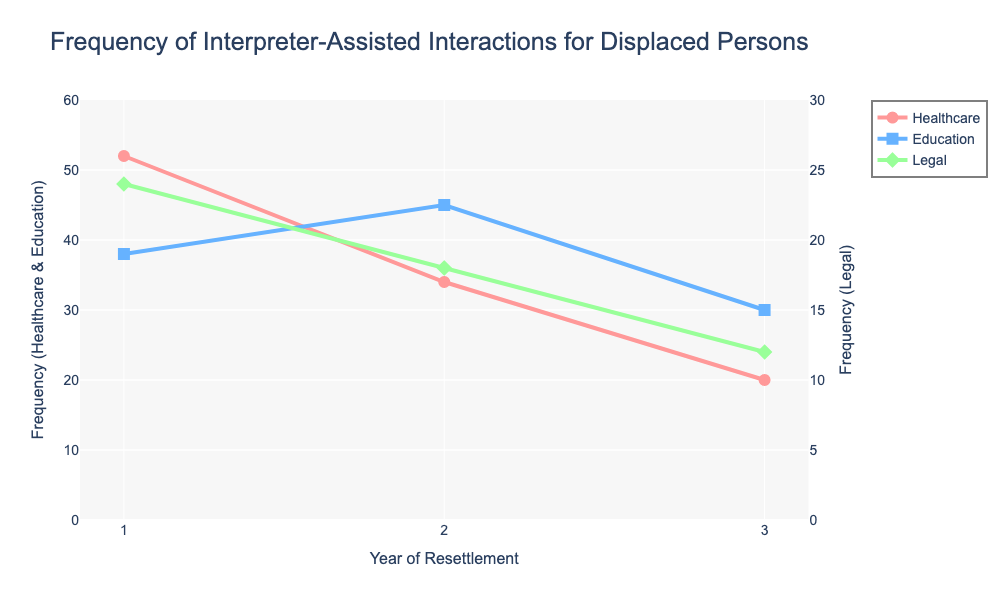What is the frequency of interpreter-assisted interactions in healthcare in the first year? The frequency of interpreter-assisted interactions in healthcare in the first year can be directly read from the figure where the year is marked as 1 and the healthcare data is depicted by the red line.
Answer: 52 Which public service area had the highest frequency of interpreter-assisted interactions in the second year? By comparing the frequency values for healthcare (34), education (45), and legal (18) in the second year, education has the highest frequency.
Answer: Education How did the frequency of interpreter-assisted interactions in the legal service area change from the first to the third year? To find the change in frequency for legal services, subtract the value in the third year (12) from the value in the first year (24).
Answer: Decreased by 12 What's the average frequency of interpreter-assisted interactions in all three public service areas in the first year? Add the frequency values for healthcare (52), education (38), and legal (24) in the first year and divide by 3. (52 + 38 + 24) / 3 = 114 / 3
Answer: 38 Between which years did education see the highest increase in interpreter-assisted interactions? Subtract the frequency of year 1 from year 2 (45 - 38 = 7) and of year 2 from year 3 (30 - 45 = -15). The highest increase is from year 1 to year 2.
Answer: Between Year 1 and Year 2 In the third year, which public service area had the least frequency of interpreter-assisted interactions? Compare the frequencies of healthcare (20), education (30), and legal (12) in the third year. Legal has the least frequency.
Answer: Legal What is the total frequency of interpreter-assisted interactions in healthcare over the three years? Sum the frequency values for healthcare in all three years: 52 + 34 + 20 = 106
Answer: 106 Is there a trend in the frequency of interpreter-assisted interactions in healthcare from year 1 to year 3? Observe the values and trend line for healthcare across the three years: from 52 in the first year, dropping to 34 in the second year, and then to 20 in the third year.
Answer: Decreasing trend Which year had a higher frequency of interpreter-assisted interactions in education compared to healthcare? Compare the frequencies of healthcare and education for each year: Year 2 (Education: 45, Healthcare: 34) is the only year where education had higher frequency than healthcare.
Answer: Year 2 